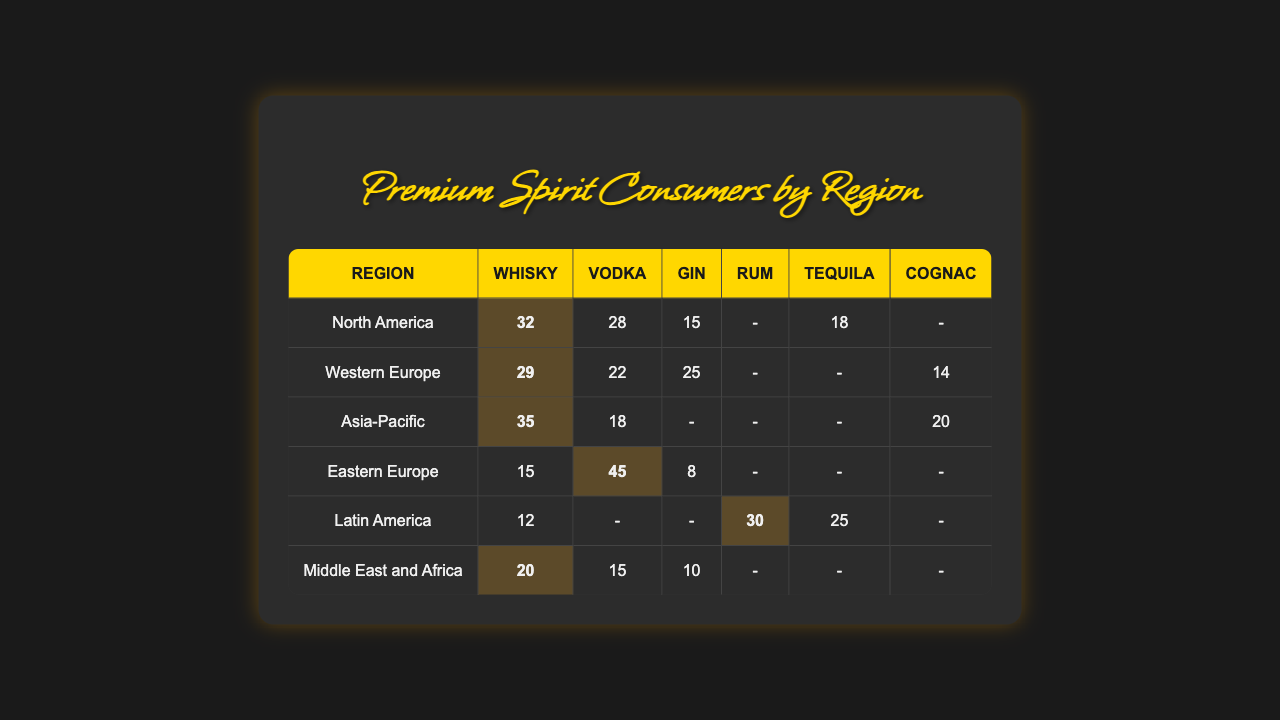What premium spirit is most popular in North America? In North America, the values for each spirit are Whisky (32), Vodka (28), Gin (15), and Tequila (18). The highest value is for Whisky, which is 32.
Answer: Whisky Which region has the highest Vodka consumption? The table shows Eastern Europe with Vodka consumption at 45, which is higher than the other regions' Vodka values.
Answer: Eastern Europe What is the total consumption of Tequila in Latin America? Latin America has a Tequila value of 25. Since Tequila is the only spirit listed for that region in the data, the total is simply 25.
Answer: 25 Is Cognac consumed in North America? In the North America row, there is no value listed for Cognac. The spirits present are Whisky, Vodka, Gin, and Tequila. Therefore, Cognac is not consumed in that region.
Answer: No Which spirit has the lowest overall consumption in the Asia-Pacific region? In Asia-Pacific, the respective consumption values are Whisky (35), Vodka (18), and Cognac (20). The lowest value here is for Vodka, which is 18.
Answer: Vodka What is the average consumption of Whisky across all regions? The Whisky values across regions are 32 (North America), 29 (Western Europe), 35 (Asia-Pacific), 15 (Eastern Europe), 12 (Latin America), and 20 (Middle East and Africa). Adding them yields 32 + 29 + 35 + 15 + 12 + 20 = 143, and dividing by the number of regions (6) gives an average of 143 / 6 = 23.83.
Answer: 23.83 Which region shows the highest consumption of Rum? In the provided data, only Latin America lists Rum with a value of 30. Since no other regions have Rum recorded, Latin America has the highest consumption.
Answer: Latin America If you combine the Vodka and Gin consumption in Western Europe, what is the result? The consumption values for Western Europe are Vodka (22) and Gin (25). Adding these two gives 22 + 25 = 47.
Answer: 47 Which spirit is universally absent from Eastern Europe? In Eastern Europe, the table shows values for Vodka (45), Whisky (15), and Gin (8). However, there is no entry for Tequila or Cognac, indicating these spirits are universally absent.
Answer: Tequila and Cognac How does the total premium spirit consumption in Northern America compare to the total in the Middle East and Africa? The total consumption in North America includes Whisky (32), Vodka (28), Gin (15), and Tequila (18), which sums up to 32 + 28 + 15 + 18 = 93. In the Middle East and Africa, the values are Whisky (20), Vodka (15), and Gin (10), summing up to 20 + 15 + 10 = 45. Therefore, North America has a higher total consumption (93) compared to the Middle East and Africa (45).
Answer: North America has higher total consumption 